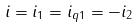<formula> <loc_0><loc_0><loc_500><loc_500>i = i _ { 1 } = i _ { q 1 } = - i _ { 2 }</formula> 